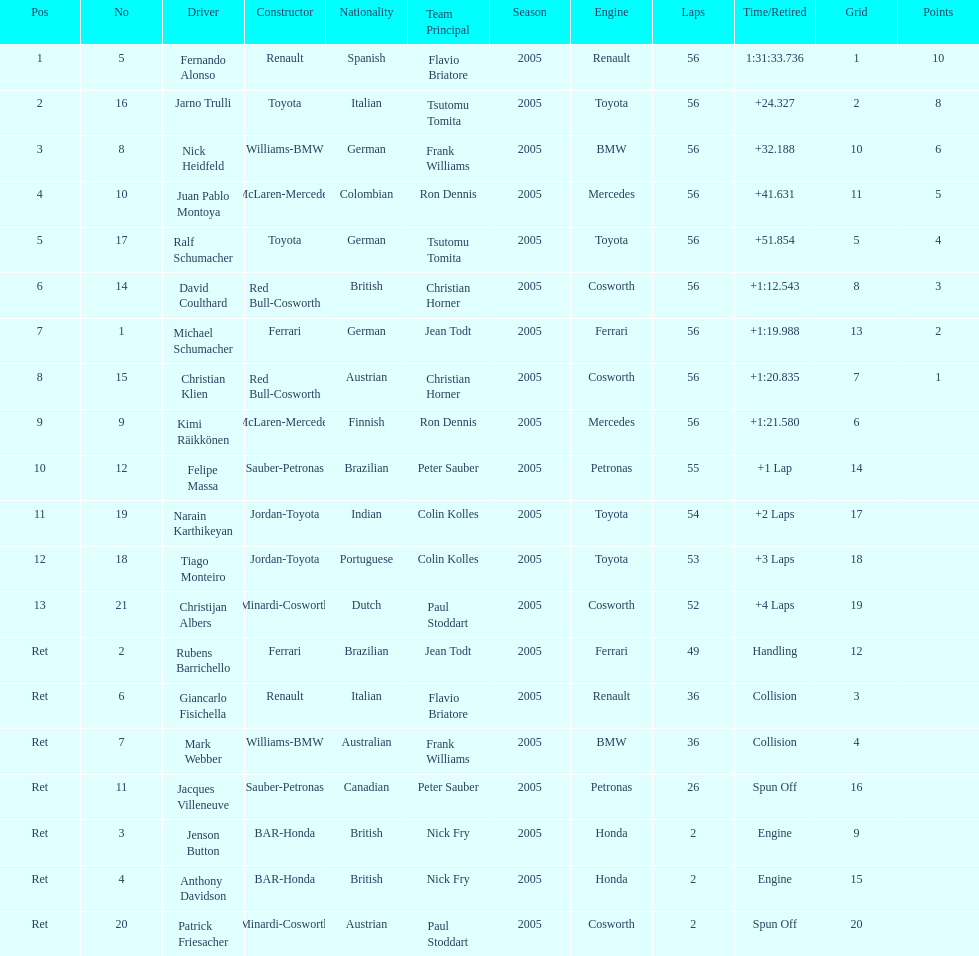How many bmws finished before webber? 1. 